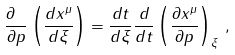Convert formula to latex. <formula><loc_0><loc_0><loc_500><loc_500>\frac { \partial \ } { \partial p } \left ( \frac { d x ^ { \mu } } { d \xi } \right ) = \frac { d t } { d \xi } \frac { d } { d t } \left ( \frac { \partial x ^ { \mu } } { \partial p } \right ) _ { \xi } \, ,</formula> 